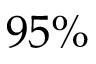<formula> <loc_0><loc_0><loc_500><loc_500>9 5 \%</formula> 